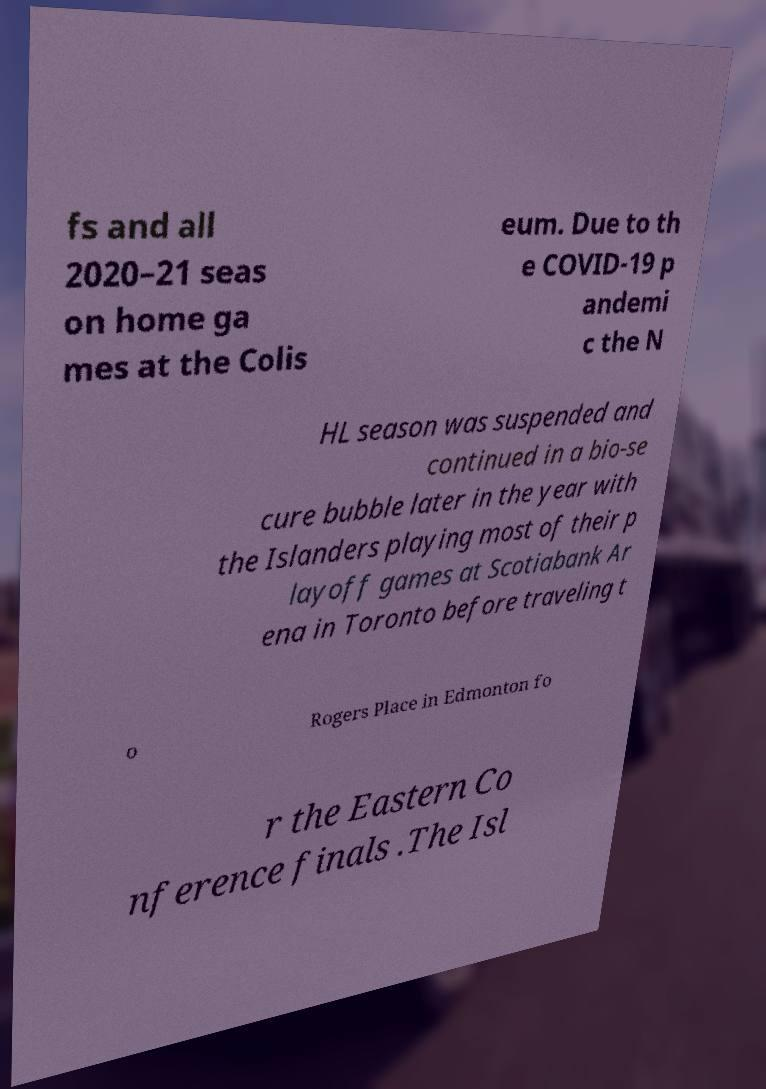I need the written content from this picture converted into text. Can you do that? fs and all 2020–21 seas on home ga mes at the Colis eum. Due to th e COVID-19 p andemi c the N HL season was suspended and continued in a bio-se cure bubble later in the year with the Islanders playing most of their p layoff games at Scotiabank Ar ena in Toronto before traveling t o Rogers Place in Edmonton fo r the Eastern Co nference finals .The Isl 